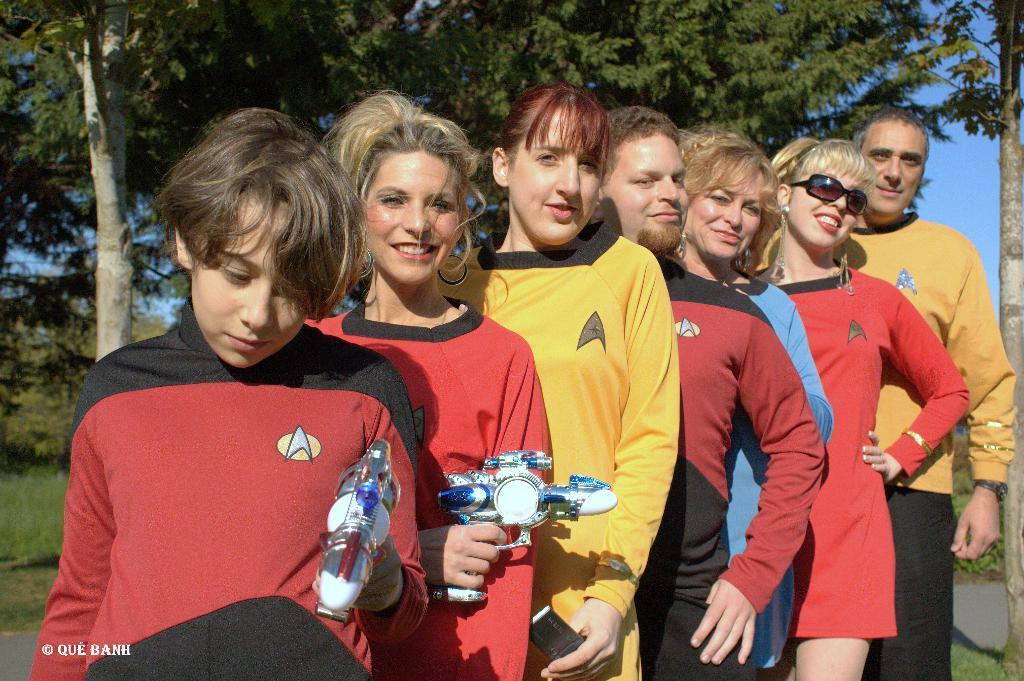How would you summarize this image in a sentence or two? In the foreground of the picture I can see a two men and five women. There are two women on the left side and they are holding the toy weapon in their hand. In the background, I can see the trees. 